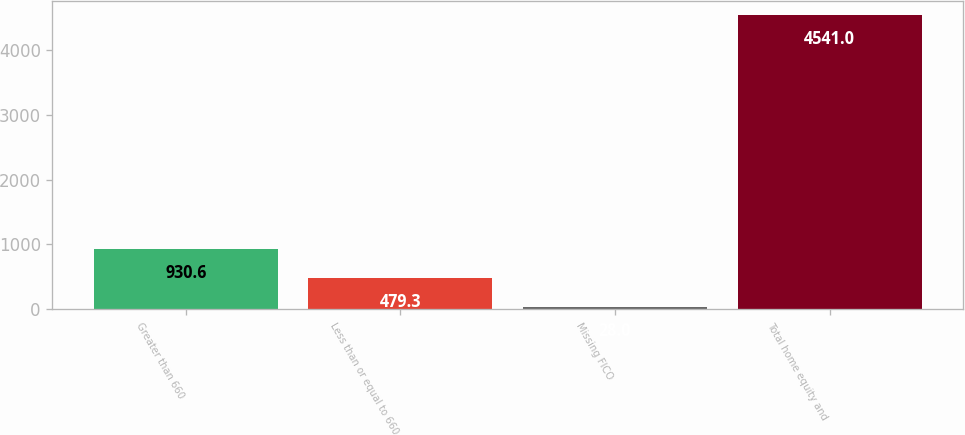Convert chart to OTSL. <chart><loc_0><loc_0><loc_500><loc_500><bar_chart><fcel>Greater than 660<fcel>Less than or equal to 660<fcel>Missing FICO<fcel>Total home equity and<nl><fcel>930.6<fcel>479.3<fcel>28<fcel>4541<nl></chart> 